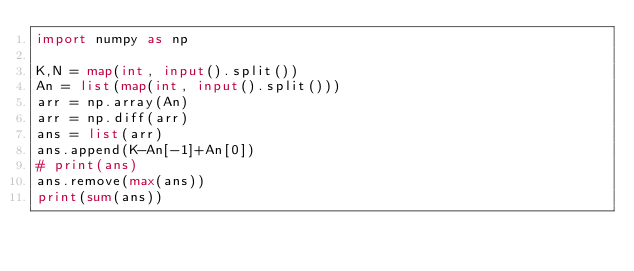<code> <loc_0><loc_0><loc_500><loc_500><_Python_>import numpy as np

K,N = map(int, input().split())
An = list(map(int, input().split()))
arr = np.array(An)
arr = np.diff(arr)
ans = list(arr)
ans.append(K-An[-1]+An[0])
# print(ans)
ans.remove(max(ans))
print(sum(ans))</code> 